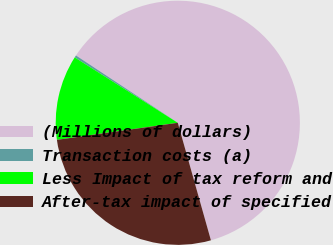Convert chart to OTSL. <chart><loc_0><loc_0><loc_500><loc_500><pie_chart><fcel>(Millions of dollars)<fcel>Transaction costs (a)<fcel>Less Impact of tax reform and<fcel>After-tax impact of specified<nl><fcel>61.33%<fcel>0.3%<fcel>11.23%<fcel>27.14%<nl></chart> 